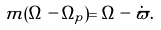Convert formula to latex. <formula><loc_0><loc_0><loc_500><loc_500>m ( \Omega - \Omega _ { p } ) = \Omega - \dot { \varpi } .</formula> 